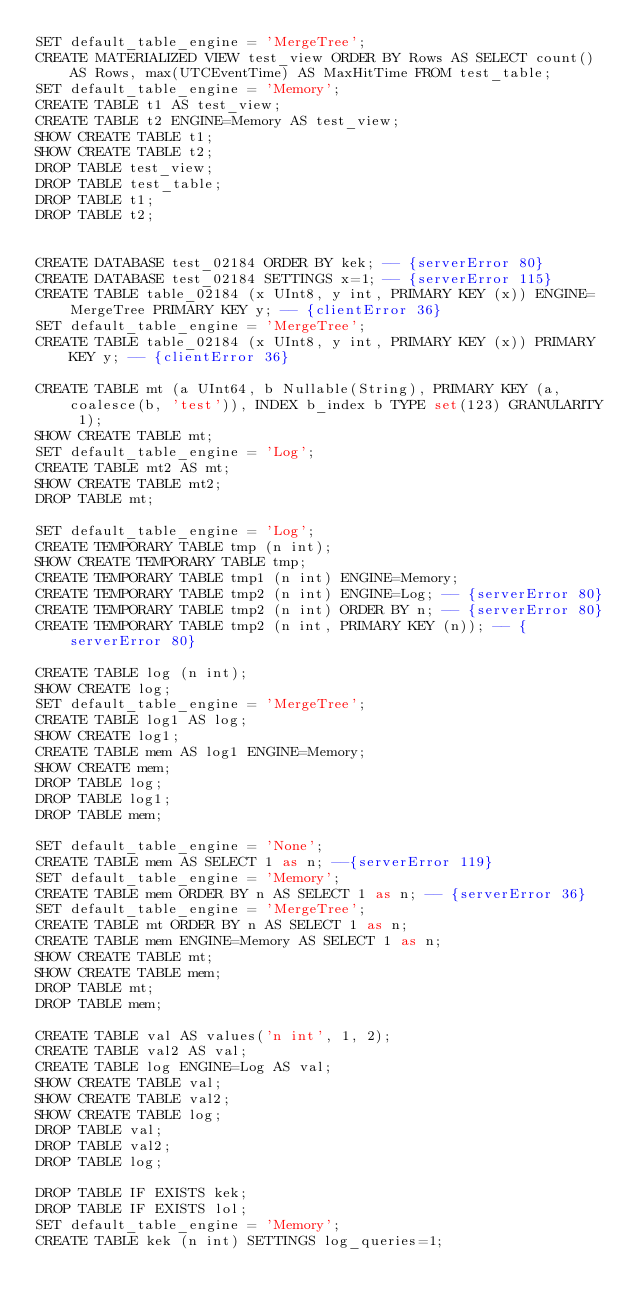<code> <loc_0><loc_0><loc_500><loc_500><_SQL_>SET default_table_engine = 'MergeTree';
CREATE MATERIALIZED VIEW test_view ORDER BY Rows AS SELECT count() AS Rows, max(UTCEventTime) AS MaxHitTime FROM test_table;
SET default_table_engine = 'Memory';
CREATE TABLE t1 AS test_view;
CREATE TABLE t2 ENGINE=Memory AS test_view;
SHOW CREATE TABLE t1;
SHOW CREATE TABLE t2;
DROP TABLE test_view;
DROP TABLE test_table;
DROP TABLE t1;
DROP TABLE t2;


CREATE DATABASE test_02184 ORDER BY kek; -- {serverError 80}
CREATE DATABASE test_02184 SETTINGS x=1; -- {serverError 115}
CREATE TABLE table_02184 (x UInt8, y int, PRIMARY KEY (x)) ENGINE=MergeTree PRIMARY KEY y; -- {clientError 36}
SET default_table_engine = 'MergeTree';
CREATE TABLE table_02184 (x UInt8, y int, PRIMARY KEY (x)) PRIMARY KEY y; -- {clientError 36}

CREATE TABLE mt (a UInt64, b Nullable(String), PRIMARY KEY (a, coalesce(b, 'test')), INDEX b_index b TYPE set(123) GRANULARITY 1);
SHOW CREATE TABLE mt;
SET default_table_engine = 'Log';
CREATE TABLE mt2 AS mt;
SHOW CREATE TABLE mt2;
DROP TABLE mt;

SET default_table_engine = 'Log';
CREATE TEMPORARY TABLE tmp (n int);
SHOW CREATE TEMPORARY TABLE tmp;
CREATE TEMPORARY TABLE tmp1 (n int) ENGINE=Memory;
CREATE TEMPORARY TABLE tmp2 (n int) ENGINE=Log; -- {serverError 80}
CREATE TEMPORARY TABLE tmp2 (n int) ORDER BY n; -- {serverError 80}
CREATE TEMPORARY TABLE tmp2 (n int, PRIMARY KEY (n)); -- {serverError 80}

CREATE TABLE log (n int);
SHOW CREATE log;
SET default_table_engine = 'MergeTree';
CREATE TABLE log1 AS log;
SHOW CREATE log1;
CREATE TABLE mem AS log1 ENGINE=Memory;
SHOW CREATE mem;
DROP TABLE log;
DROP TABLE log1;
DROP TABLE mem;

SET default_table_engine = 'None';
CREATE TABLE mem AS SELECT 1 as n; --{serverError 119}
SET default_table_engine = 'Memory';
CREATE TABLE mem ORDER BY n AS SELECT 1 as n; -- {serverError 36}
SET default_table_engine = 'MergeTree';
CREATE TABLE mt ORDER BY n AS SELECT 1 as n;
CREATE TABLE mem ENGINE=Memory AS SELECT 1 as n;
SHOW CREATE TABLE mt;
SHOW CREATE TABLE mem;
DROP TABLE mt;
DROP TABLE mem;

CREATE TABLE val AS values('n int', 1, 2);
CREATE TABLE val2 AS val;
CREATE TABLE log ENGINE=Log AS val;
SHOW CREATE TABLE val;
SHOW CREATE TABLE val2;
SHOW CREATE TABLE log;
DROP TABLE val;
DROP TABLE val2;
DROP TABLE log;

DROP TABLE IF EXISTS kek;
DROP TABLE IF EXISTS lol;
SET default_table_engine = 'Memory';
CREATE TABLE kek (n int) SETTINGS log_queries=1;</code> 